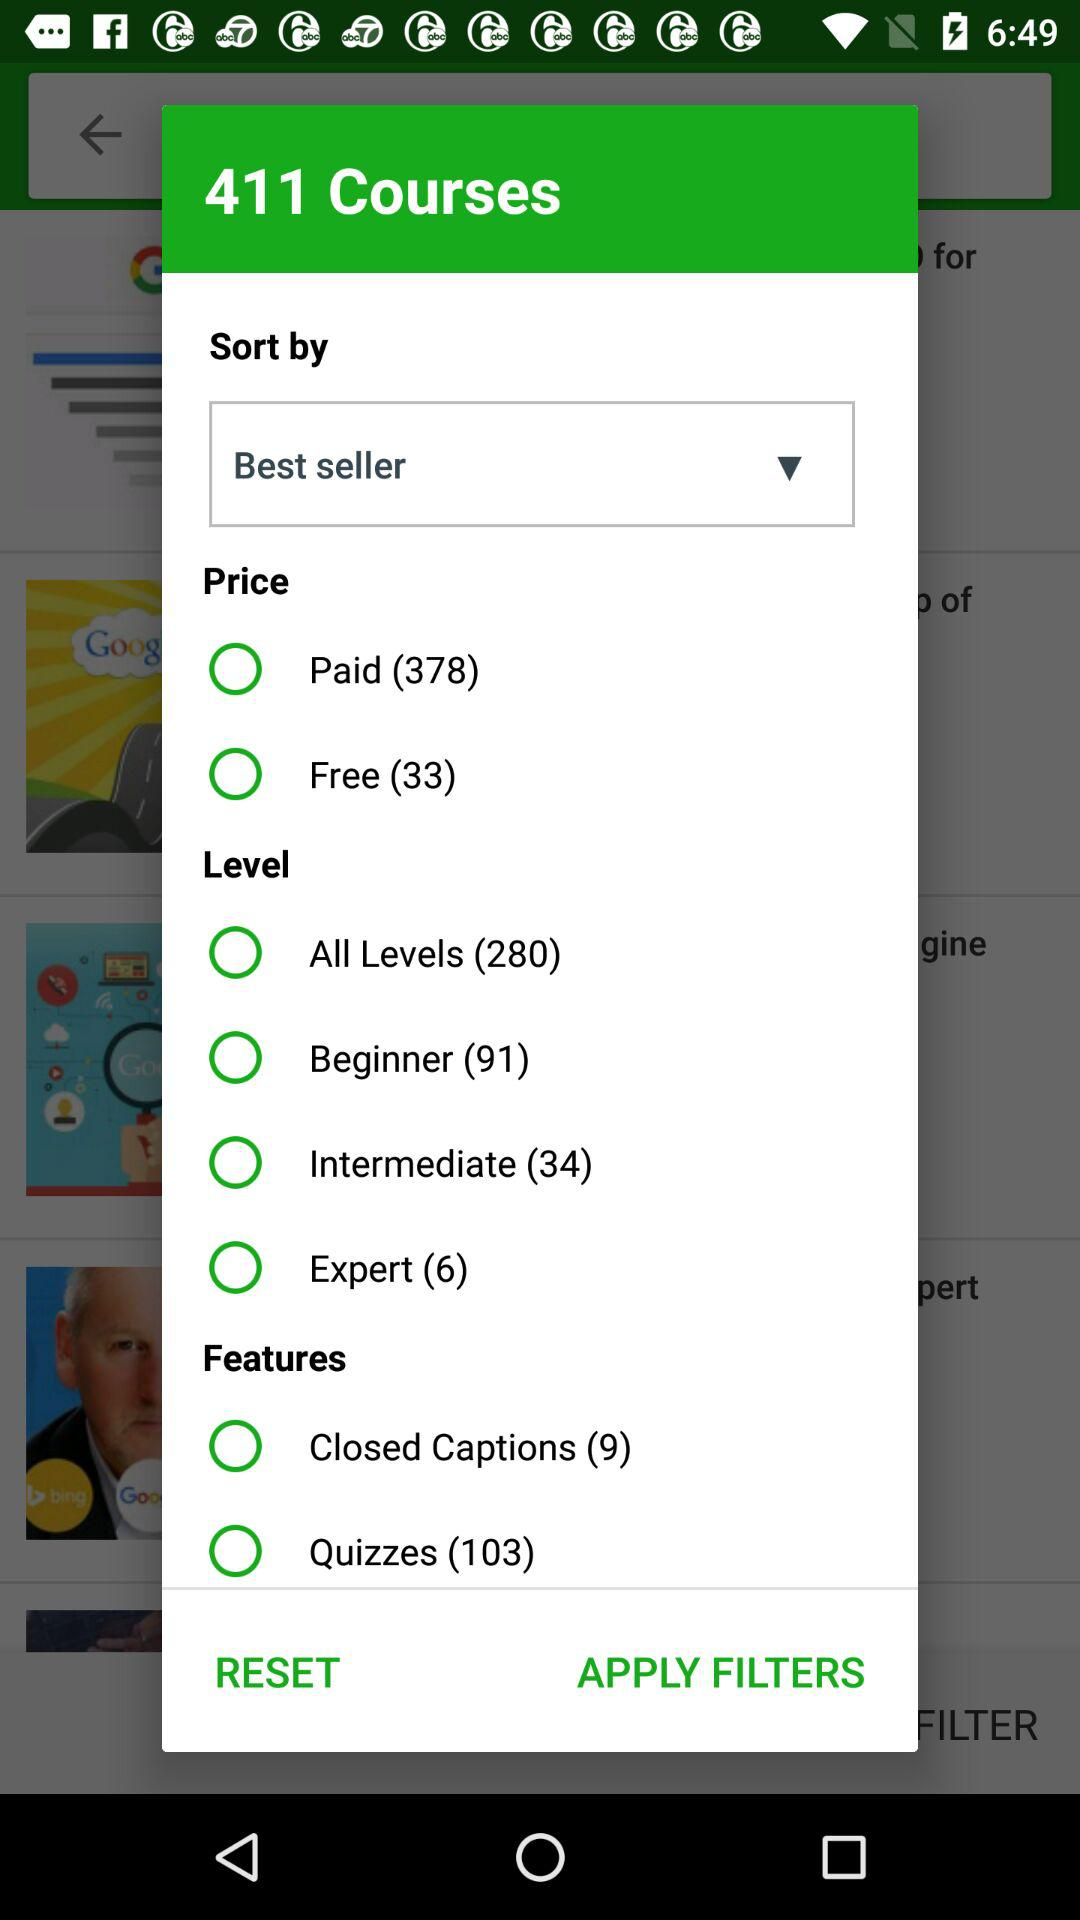How many courses in total are there? There are a total of 411 courses. 